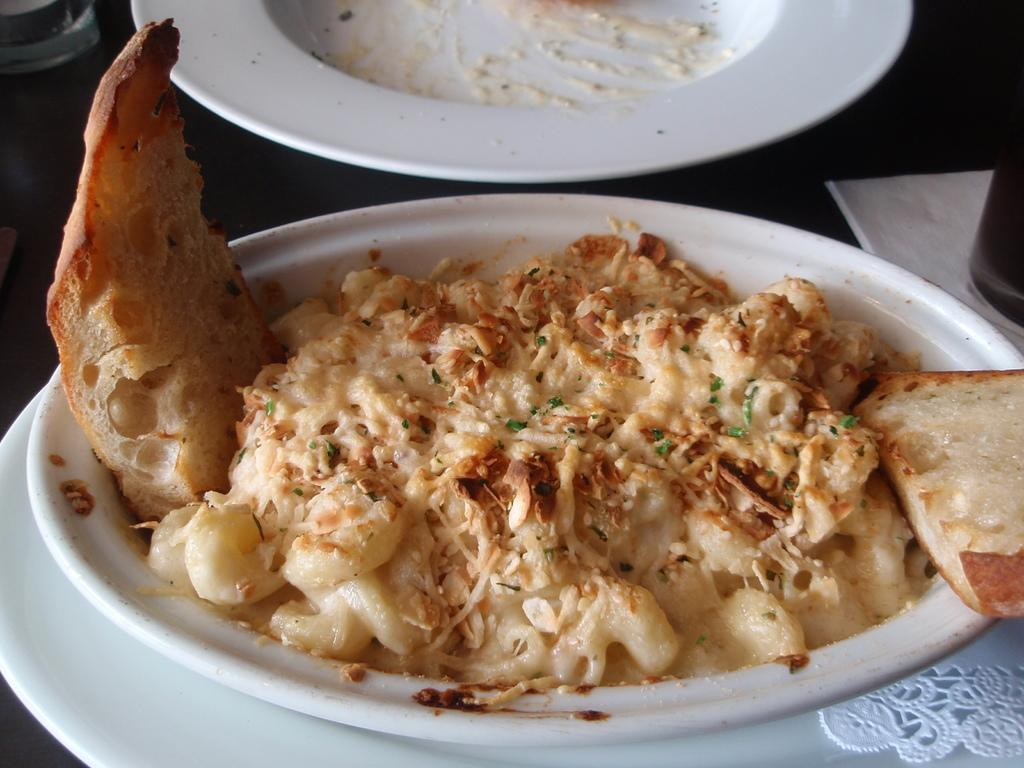What piece of furniture is present in the image? There is a table in the image. What items are placed on the table? There are plates, food items, a glass, and tissue on the table. Can you describe the food items on the table? Unfortunately, the specific food items cannot be determined from the provided facts. What might be used for drinking in the image? There is a glass on the table, which might be used for drinking. Is there a stranger in the image smashing the plates with a straw? No, there is no stranger or any smashing of plates with a straw in the image. 